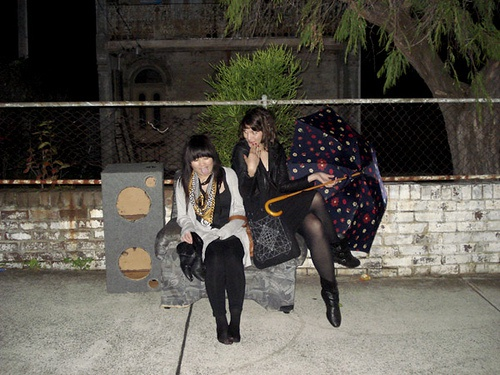Describe the objects in this image and their specific colors. I can see people in black, gray, darkgray, and maroon tones, people in black, darkgray, lightgray, and gray tones, umbrella in black, maroon, and gray tones, and handbag in black and gray tones in this image. 